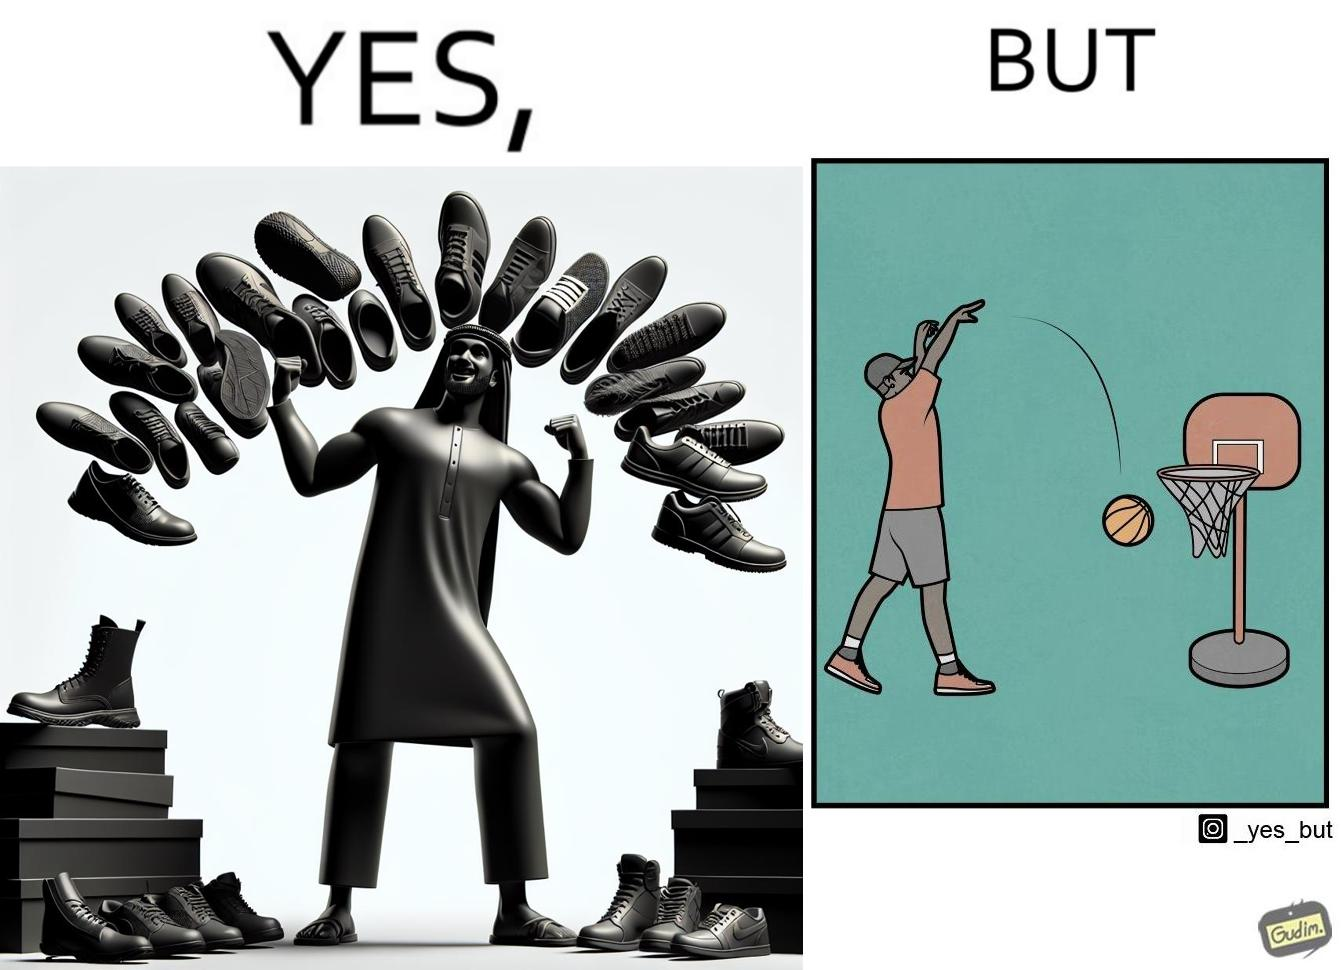Describe what you see in the left and right parts of this image. In the left part of the image: a person flexing his shoes collection In the right part of the image: a person not able to net a basketball even with a low height net 